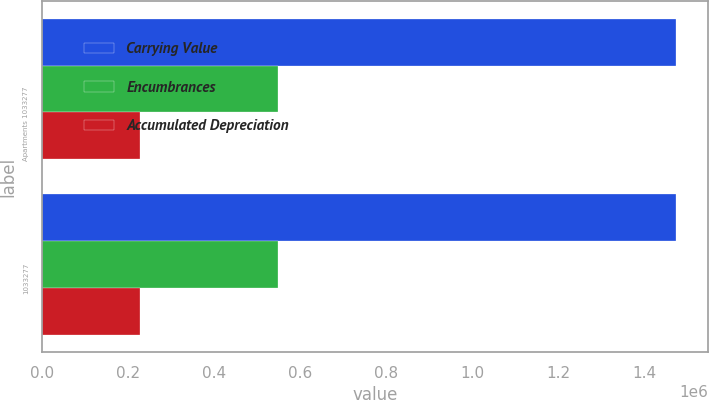<chart> <loc_0><loc_0><loc_500><loc_500><stacked_bar_chart><ecel><fcel>Apartments 1033277<fcel>1033277<nl><fcel>Carrying Value<fcel>1.47466e+06<fcel>1.47466e+06<nl><fcel>Encumbrances<fcel>547965<fcel>547965<nl><fcel>Accumulated Depreciation<fcel>227325<fcel>227325<nl></chart> 